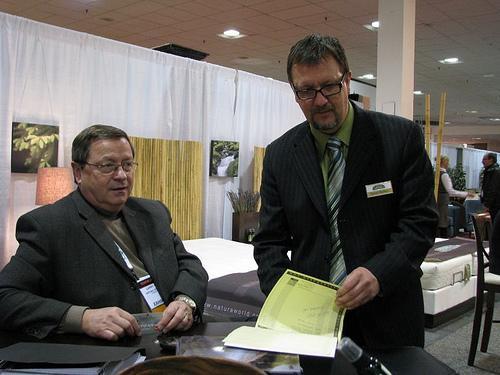How many people are visible?
Give a very brief answer. 2. How many beds are there?
Give a very brief answer. 2. 